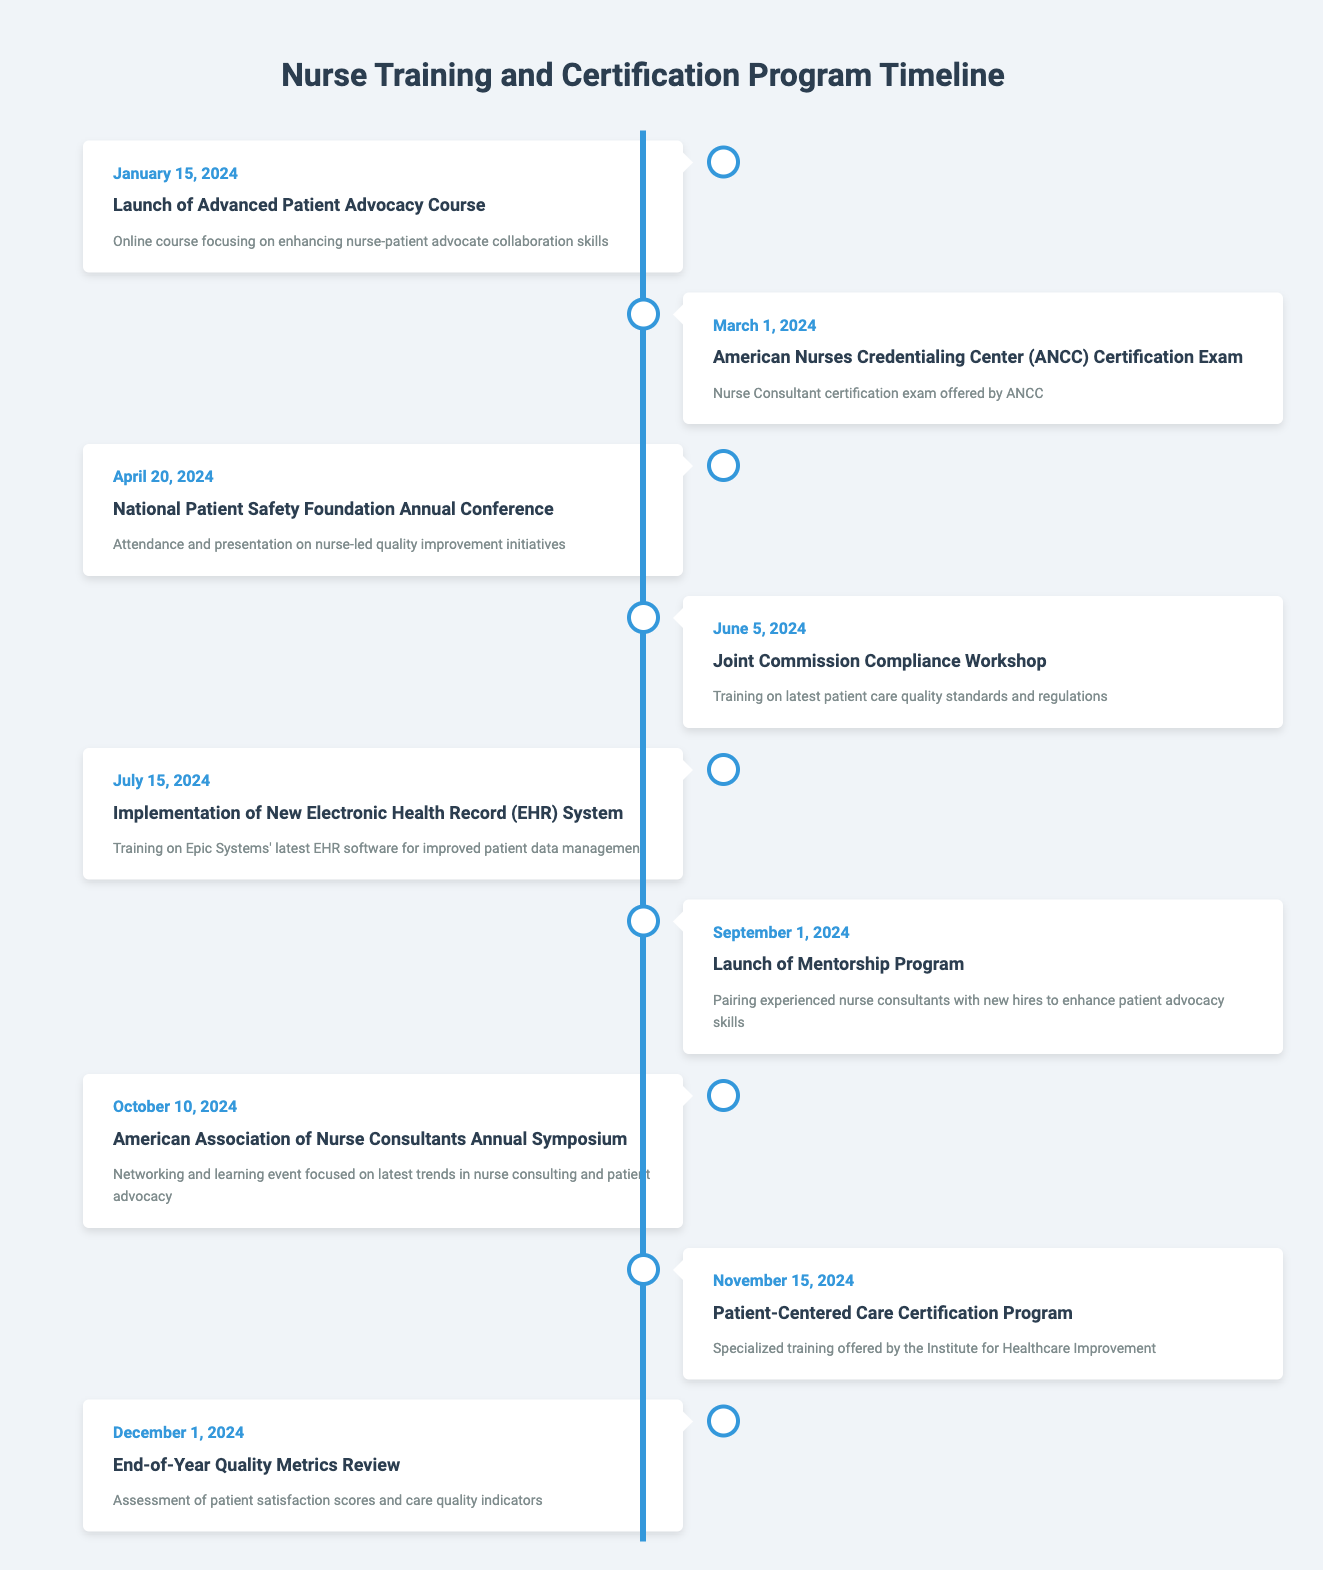What is the date for the launch of the Advanced Patient Advocacy Course? The launch of the Advanced Patient Advocacy Course is scheduled for January 15, 2024, as stated in the table.
Answer: January 15, 2024 How many events occur between March 1 and June 5, 2024? The events happening between March 1 and June 5, 2024, are: the ANCC Certification Exam on March 1, the National Patient Safety Foundation Annual Conference on April 20, and the Joint Commission Compliance Workshop on June 5. Therefore, there are 3 events in this range.
Answer: 3 Is there a training session related to Electronic Health Records in 2024? Yes, the Implementation of New Electronic Health Record (EHR) System is listed for July 15, 2024.
Answer: Yes Which event occurs last in the year 2024? The last event listed in the timeline is the End-of-Year Quality Metrics Review, which occurs on December 1, 2024.
Answer: End-of-Year Quality Metrics Review What is the difference in days between the launch of the Mentorship Program and the Patient-Centered Care Certification Program? The Mentorship Program launches on September 1, 2024, and the Patient-Centered Care Certification Program begins on November 15, 2024. The difference between these dates is 75 days.
Answer: 75 days How many events are scheduled in the second half of the year (July to December)? The scheduled events in the second half of the year are: Implementation of New Electronic Health Record on July 15, Launch of Mentorship Program on September 1, American Association of Nurse Consultants Annual Symposium on October 10, Patient-Centered Care Certification Program on November 15, and End-of-Year Quality Metrics Review on December 1. This sums up to 5 events.
Answer: 5 Was there a conference related to patient safety in 2024? Yes, the National Patient Safety Foundation Annual Conference is scheduled for April 20, 2024.
Answer: Yes If we categorize events into workshops, courses, and conferences, how many workshops are listed? The timeline includes the Joint Commission Compliance Workshop on June 5, 2024, and no other workshops are mentioned. Therefore, there is 1 workshop listed.
Answer: 1 What are the two events that occur closest to each other in terms of dates? The events closest in date are the launch of the Advanced Patient Advocacy Course on January 15, 2024, and the ANCC Certification Exam on March 1, 2024. The interval between these two events is 45 days, making them the closest.
Answer: Advanced Patient Advocacy Course and ANCC Certification Exam 